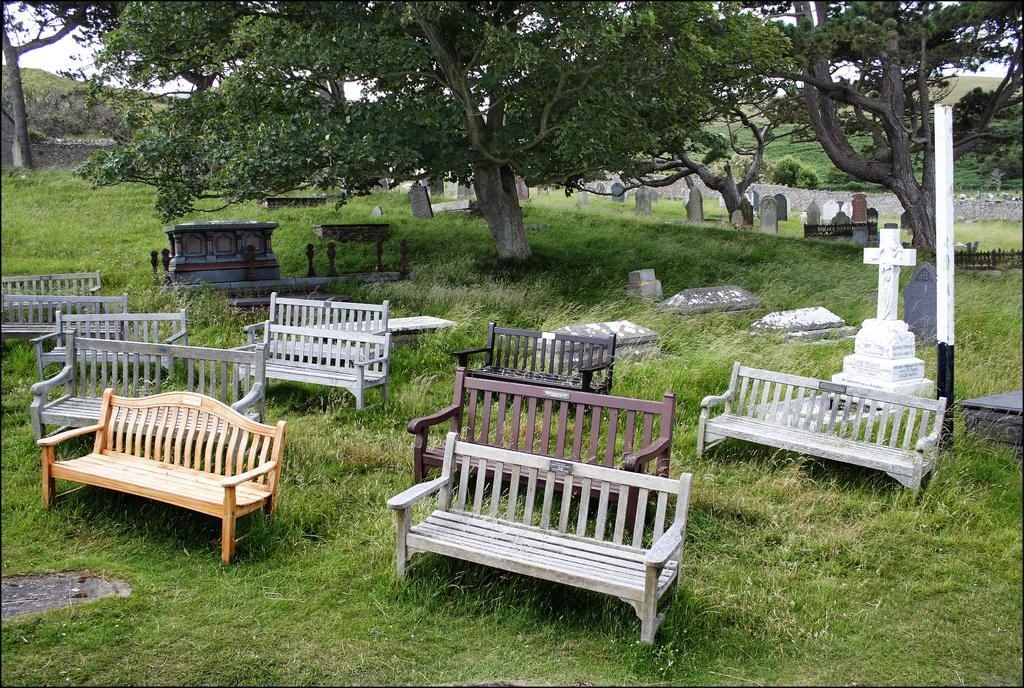What type of seating is visible on the ground in the image? There are benches on the ground in the image. What can be found on the right side of the image? There are gravestones on the right side of the image. What type of vegetation covers the ground in the image? There is grass on the ground in the image. What is visible in the background of the image? There are trees in the background of the image. What brand of toothpaste is advertised on the gravestones in the image? There is no toothpaste or advertisement present on the gravestones in the image. What type of blade is visible on the benches in the image? There are no blades visible on the benches in the image. 